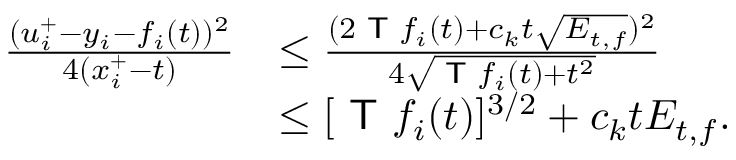<formula> <loc_0><loc_0><loc_500><loc_500>\begin{array} { r l } { \frac { ( u _ { i } ^ { + } - y _ { i } - f _ { i } ( t ) ) ^ { 2 } } { 4 ( x _ { i } ^ { + } - t ) } } & { \leq \frac { ( 2 T f _ { i } ( t ) + c _ { k } t \sqrt { E _ { t , f } } ) ^ { 2 } } { 4 \sqrt { T f _ { i } ( t ) + t ^ { 2 } } } } \\ & { \leq [ T f _ { i } ( t ) ] ^ { 3 / 2 } + c _ { k } t E _ { t , f } . } \end{array}</formula> 